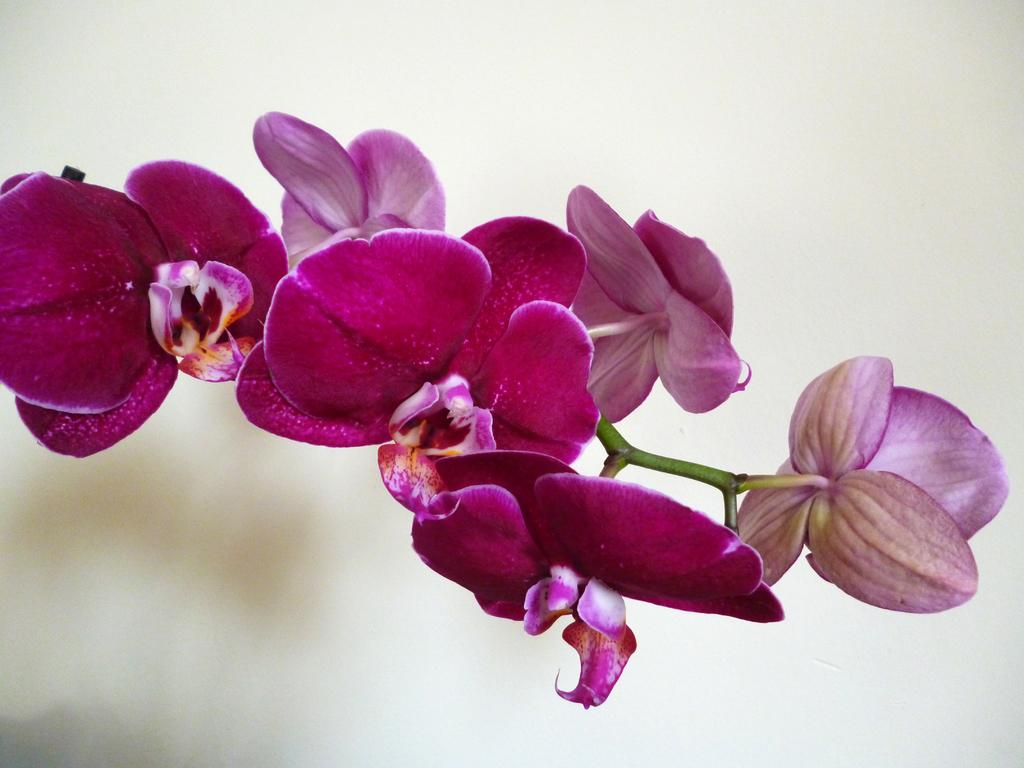What is the main subject of focus of the image? The main focus of the image is flowers. Can you describe the flowers in more detail? The flowers have visible stems in the image. What can be observed about the background of the image? The background of the image is blurry. How many women are sitting in the tub in the image? There is no tub or women present in the image; it features flowers with visible stems and a blurry background. 